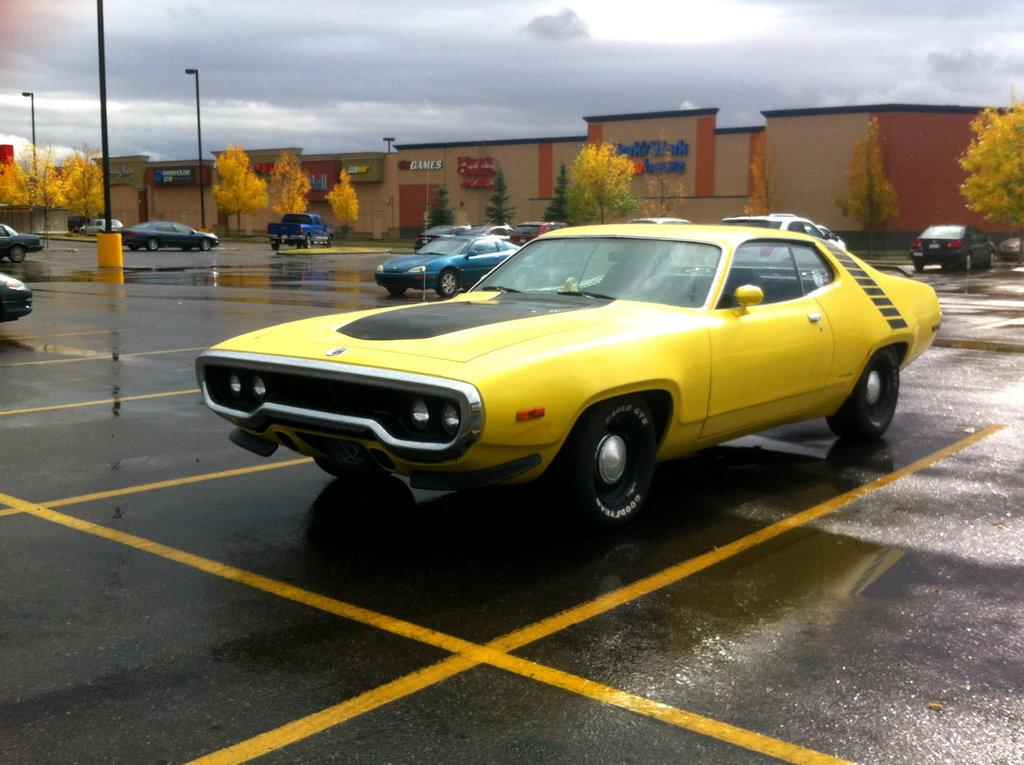What types of objects are present in the image? There are vehicles in the image. Can you describe the appearance of the vehicles? The vehicles are in different colors. What can be seen in the background of the image? There is a building, trees, and a light pole visible in the background. How would you describe the sky in the image? The sky appears to be white in color. How many necks can be seen on the vehicles in the image? There are no necks present on the vehicles in the image, as vehicles do not have necks. Can you describe the kicking motion of the trees in the background? There is no kicking motion present in the image; the trees are stationary. 